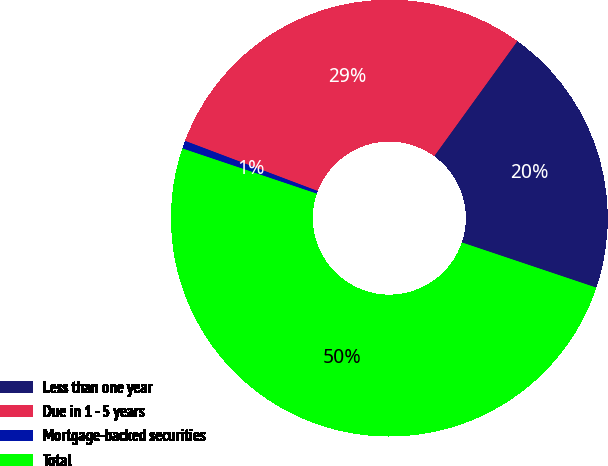Convert chart to OTSL. <chart><loc_0><loc_0><loc_500><loc_500><pie_chart><fcel>Less than one year<fcel>Due in 1 - 5 years<fcel>Mortgage-backed securities<fcel>Total<nl><fcel>20.2%<fcel>29.21%<fcel>0.59%<fcel>50.0%<nl></chart> 